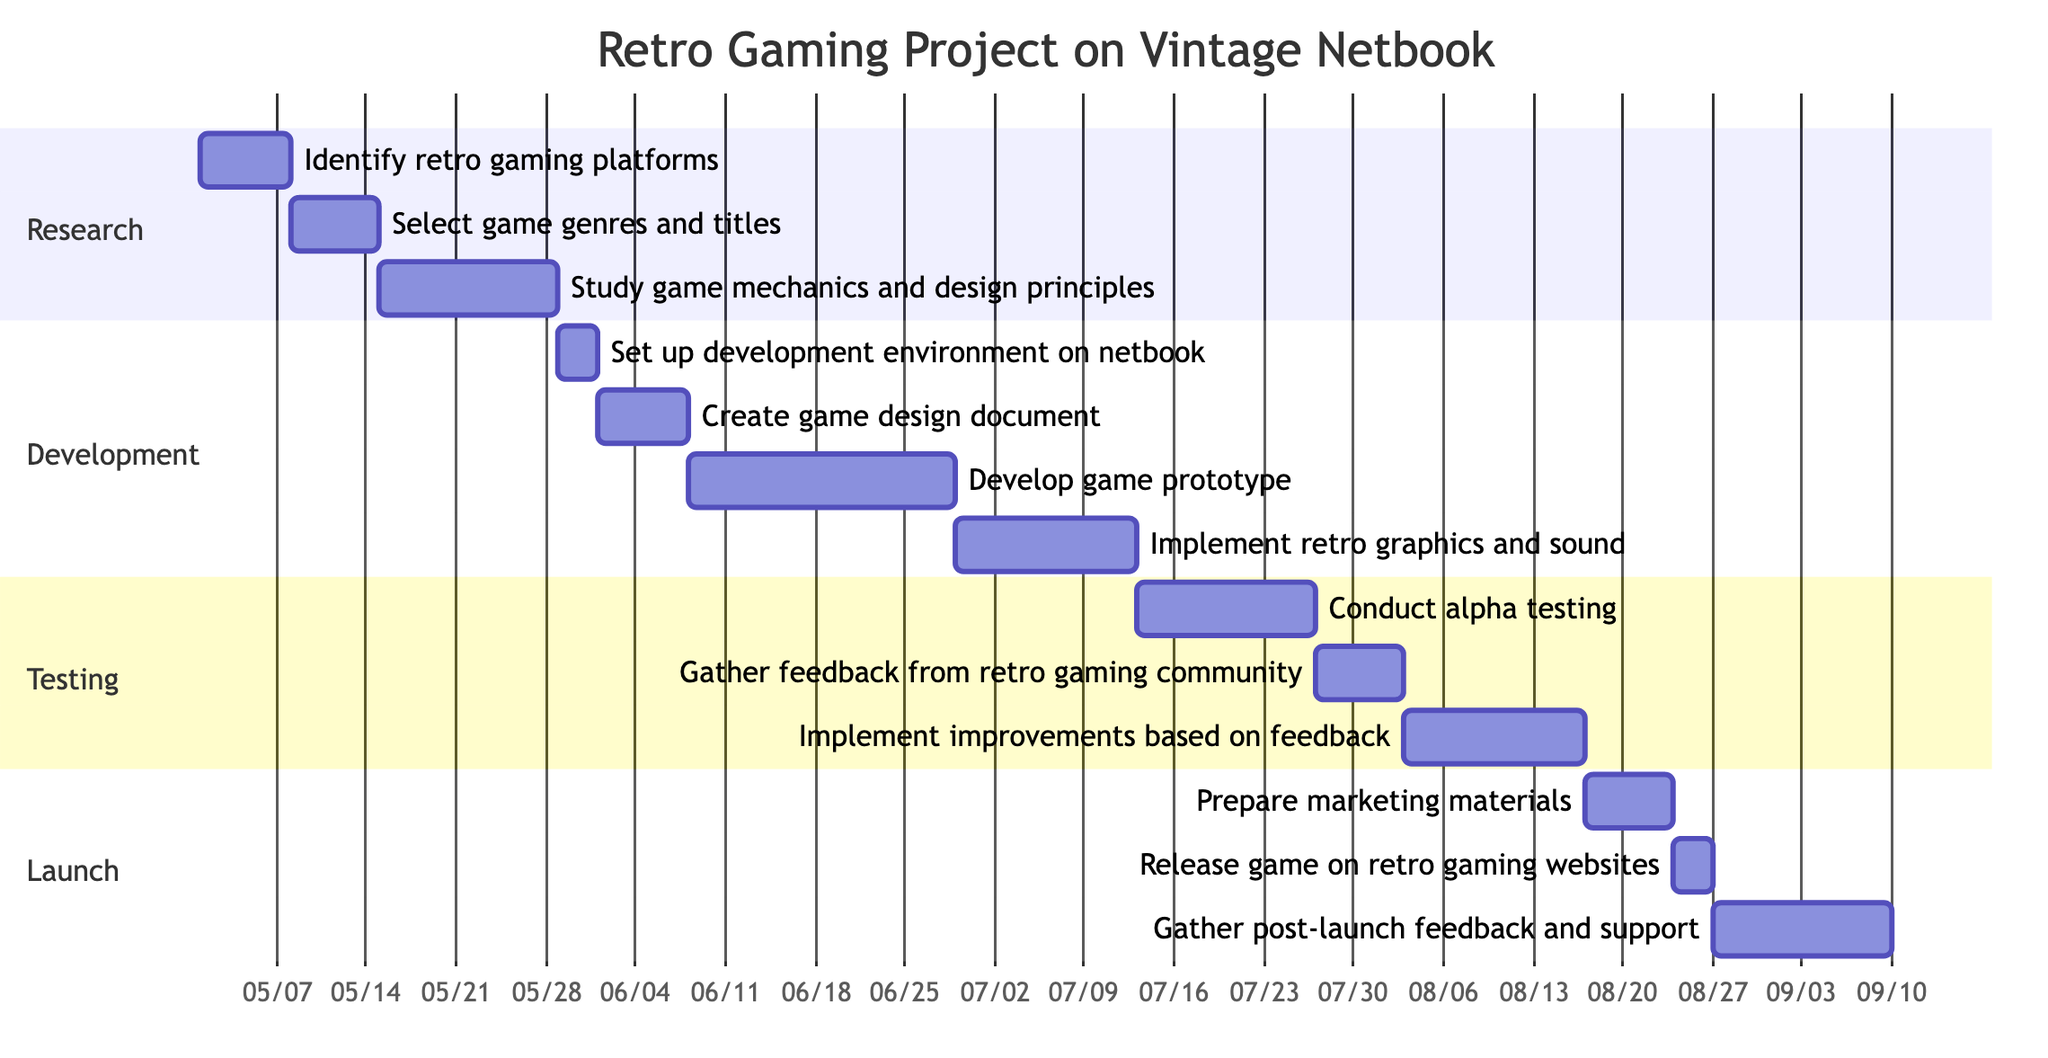What is the total duration of the Research phase? The Research phase has three tasks: "Identify retro gaming platforms" takes 1 week, "Select game genres and titles" takes 1 week, and "Study game mechanics and design principles" takes 2 weeks. Adding these durations together gives 1 + 1 + 2 = 4 weeks.
Answer: 4 weeks Which task in the Development phase has the longest duration? In the Development phase, the tasks and their durations are: "Set up development environment on netbook" (3 days), "Create game design document" (1 week), "Develop game prototype" (3 weeks), and "Implement retro graphics and sound" (2 weeks). The task with the longest duration is "Develop game prototype" at 3 weeks.
Answer: Develop game prototype How many tasks are there in the Testing phase? The Testing phase consists of three tasks: "Conduct alpha testing," "Gather feedback from retro gaming community," and "Implement improvements based on feedback." Therefore, there are 3 tasks in total.
Answer: 3 tasks What comes immediately after "Gather feedback from retro gaming community"? Looking at the diagram, "Gather feedback from retro gaming community" is followed immediately by "Implement improvements based on feedback" in the Testing phase.
Answer: Implement improvements based on feedback What is the duration of the task "Release game on retro gaming websites"? The task "Release game on retro gaming websites" has a duration of 3 days as specified in the Launch phase of the diagram.
Answer: 3 days What is the relationship between "Study game mechanics and design principles" and "Set up development environment on netbook"? "Study game mechanics and design principles" occurs in the Research phase and is completed before "Set up development environment on netbook," which is the first task in the Development phase. This shows a sequential relationship where one task must be completed before another can begin.
Answer: Sequential relationship How many weeks are allocated for post-launch feedback and support? In the Launch phase, the task "Gather post-launch feedback and support" is allocated 2 weeks, as indicated in the diagram.
Answer: 2 weeks 